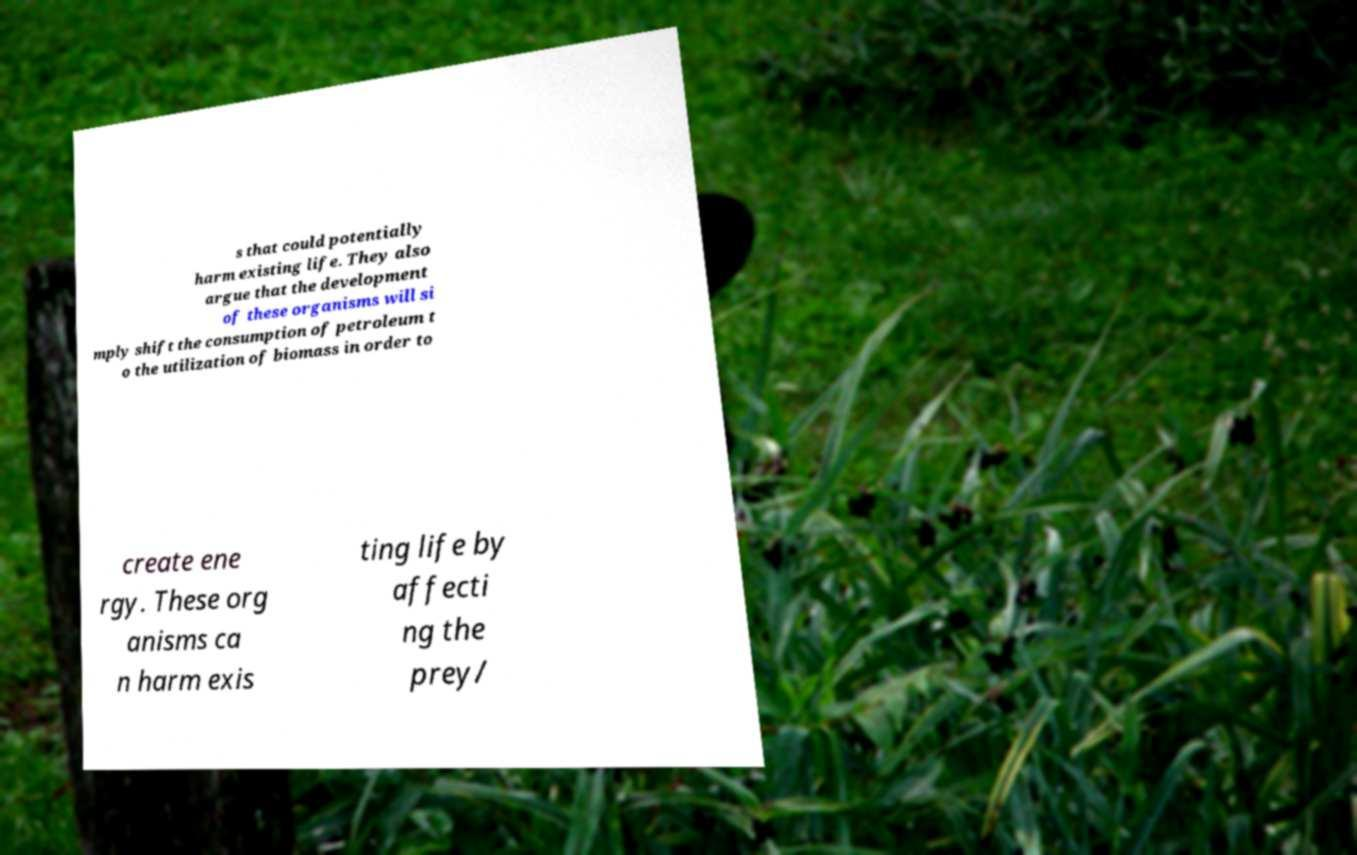I need the written content from this picture converted into text. Can you do that? s that could potentially harm existing life. They also argue that the development of these organisms will si mply shift the consumption of petroleum t o the utilization of biomass in order to create ene rgy. These org anisms ca n harm exis ting life by affecti ng the prey/ 